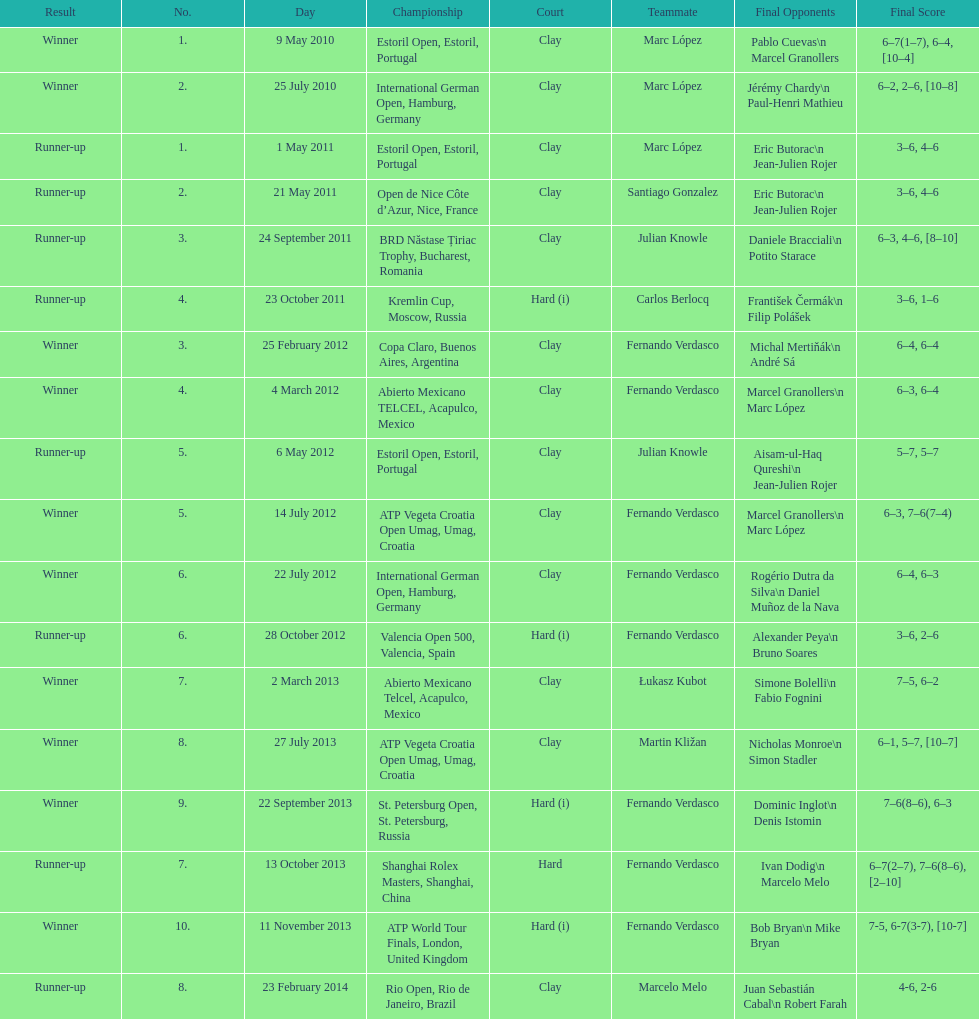Which tournament has the largest number? ATP World Tour Finals. 